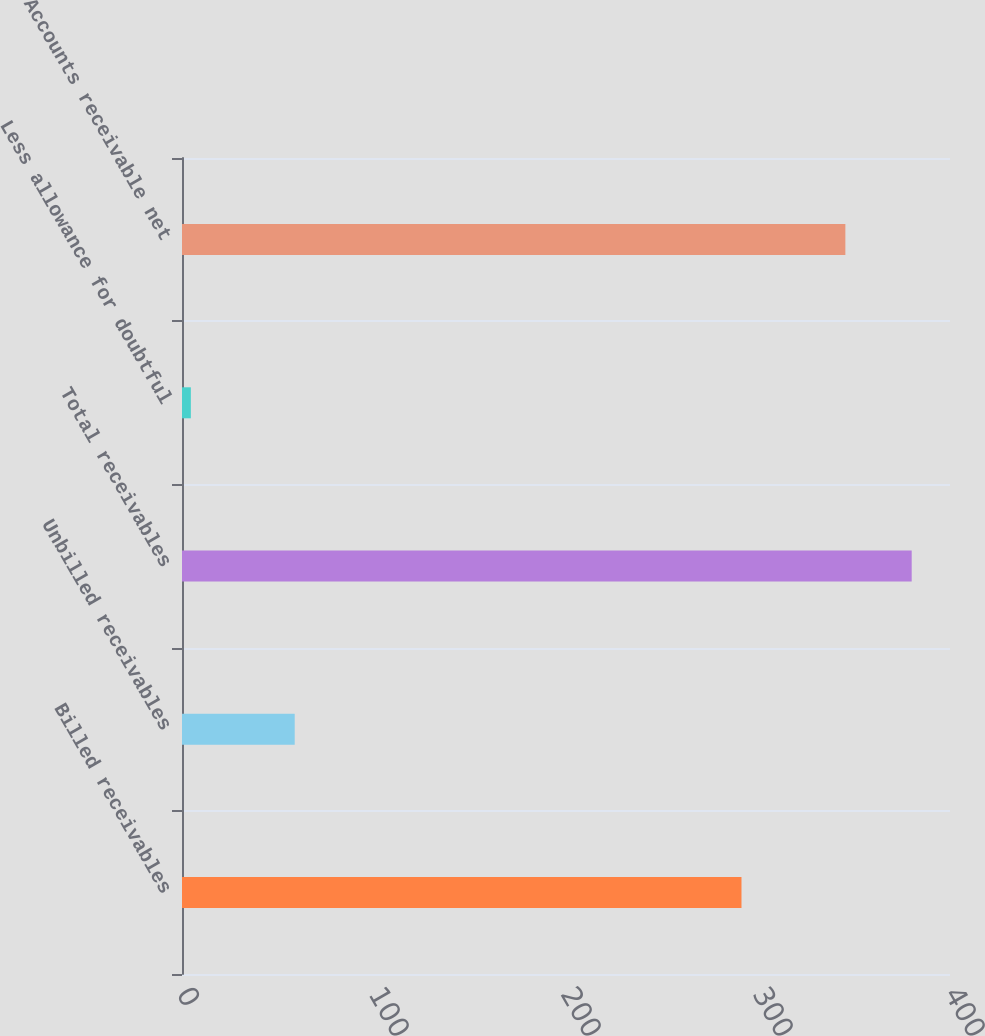Convert chart. <chart><loc_0><loc_0><loc_500><loc_500><bar_chart><fcel>Billed receivables<fcel>Unbilled receivables<fcel>Total receivables<fcel>Less allowance for doubtful<fcel>Accounts receivable net<nl><fcel>291.4<fcel>58.7<fcel>380.05<fcel>4.6<fcel>345.5<nl></chart> 